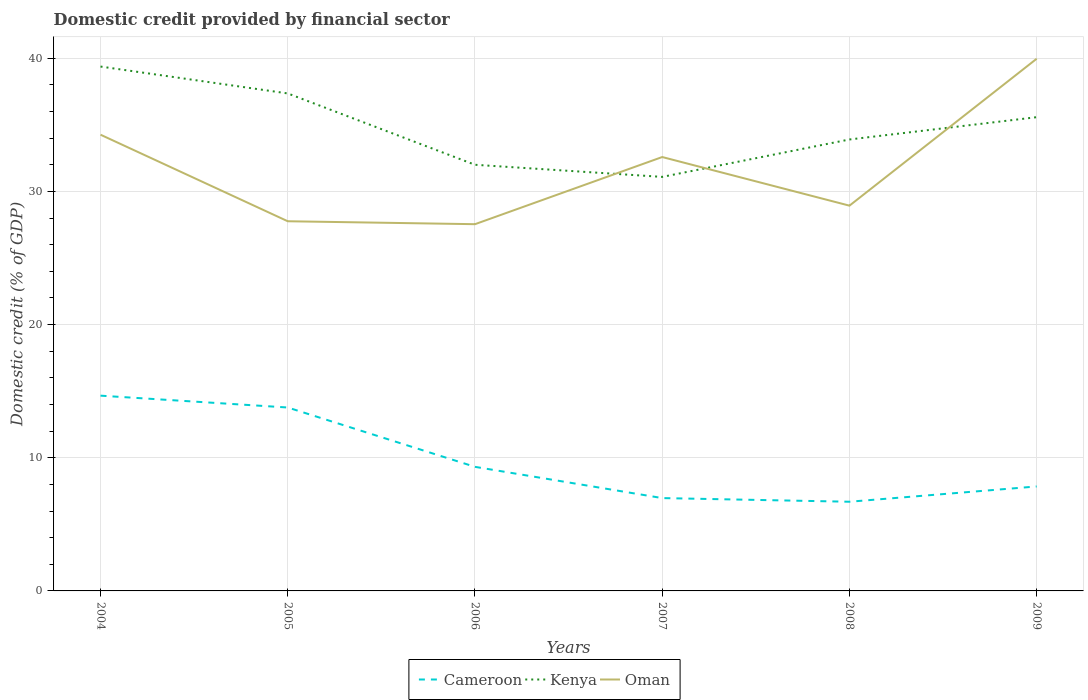Across all years, what is the maximum domestic credit in Cameroon?
Provide a short and direct response. 6.7. What is the total domestic credit in Oman in the graph?
Provide a succinct answer. -1.39. What is the difference between the highest and the second highest domestic credit in Cameroon?
Give a very brief answer. 7.97. What is the difference between two consecutive major ticks on the Y-axis?
Ensure brevity in your answer.  10. Are the values on the major ticks of Y-axis written in scientific E-notation?
Ensure brevity in your answer.  No. Where does the legend appear in the graph?
Your answer should be compact. Bottom center. How many legend labels are there?
Offer a terse response. 3. What is the title of the graph?
Your answer should be compact. Domestic credit provided by financial sector. What is the label or title of the X-axis?
Ensure brevity in your answer.  Years. What is the label or title of the Y-axis?
Your response must be concise. Domestic credit (% of GDP). What is the Domestic credit (% of GDP) in Cameroon in 2004?
Ensure brevity in your answer.  14.66. What is the Domestic credit (% of GDP) in Kenya in 2004?
Ensure brevity in your answer.  39.38. What is the Domestic credit (% of GDP) of Oman in 2004?
Give a very brief answer. 34.26. What is the Domestic credit (% of GDP) of Cameroon in 2005?
Keep it short and to the point. 13.77. What is the Domestic credit (% of GDP) of Kenya in 2005?
Ensure brevity in your answer.  37.36. What is the Domestic credit (% of GDP) in Oman in 2005?
Your response must be concise. 27.76. What is the Domestic credit (% of GDP) of Cameroon in 2006?
Provide a short and direct response. 9.32. What is the Domestic credit (% of GDP) of Kenya in 2006?
Keep it short and to the point. 32. What is the Domestic credit (% of GDP) of Oman in 2006?
Your answer should be very brief. 27.54. What is the Domestic credit (% of GDP) of Cameroon in 2007?
Provide a short and direct response. 6.97. What is the Domestic credit (% of GDP) in Kenya in 2007?
Keep it short and to the point. 31.09. What is the Domestic credit (% of GDP) of Oman in 2007?
Offer a terse response. 32.58. What is the Domestic credit (% of GDP) of Cameroon in 2008?
Offer a very short reply. 6.7. What is the Domestic credit (% of GDP) in Kenya in 2008?
Keep it short and to the point. 33.9. What is the Domestic credit (% of GDP) in Oman in 2008?
Offer a terse response. 28.93. What is the Domestic credit (% of GDP) in Cameroon in 2009?
Your response must be concise. 7.85. What is the Domestic credit (% of GDP) in Kenya in 2009?
Offer a very short reply. 35.58. What is the Domestic credit (% of GDP) of Oman in 2009?
Provide a succinct answer. 39.97. Across all years, what is the maximum Domestic credit (% of GDP) of Cameroon?
Your answer should be compact. 14.66. Across all years, what is the maximum Domestic credit (% of GDP) of Kenya?
Offer a terse response. 39.38. Across all years, what is the maximum Domestic credit (% of GDP) of Oman?
Give a very brief answer. 39.97. Across all years, what is the minimum Domestic credit (% of GDP) in Cameroon?
Provide a short and direct response. 6.7. Across all years, what is the minimum Domestic credit (% of GDP) in Kenya?
Your response must be concise. 31.09. Across all years, what is the minimum Domestic credit (% of GDP) in Oman?
Give a very brief answer. 27.54. What is the total Domestic credit (% of GDP) in Cameroon in the graph?
Your answer should be compact. 59.27. What is the total Domestic credit (% of GDP) of Kenya in the graph?
Offer a very short reply. 209.32. What is the total Domestic credit (% of GDP) in Oman in the graph?
Give a very brief answer. 191.05. What is the difference between the Domestic credit (% of GDP) in Cameroon in 2004 and that in 2005?
Your answer should be compact. 0.89. What is the difference between the Domestic credit (% of GDP) of Kenya in 2004 and that in 2005?
Provide a short and direct response. 2.02. What is the difference between the Domestic credit (% of GDP) in Oman in 2004 and that in 2005?
Your answer should be very brief. 6.5. What is the difference between the Domestic credit (% of GDP) of Cameroon in 2004 and that in 2006?
Ensure brevity in your answer.  5.35. What is the difference between the Domestic credit (% of GDP) of Kenya in 2004 and that in 2006?
Make the answer very short. 7.38. What is the difference between the Domestic credit (% of GDP) of Oman in 2004 and that in 2006?
Offer a very short reply. 6.72. What is the difference between the Domestic credit (% of GDP) of Cameroon in 2004 and that in 2007?
Provide a short and direct response. 7.69. What is the difference between the Domestic credit (% of GDP) of Kenya in 2004 and that in 2007?
Offer a very short reply. 8.29. What is the difference between the Domestic credit (% of GDP) of Oman in 2004 and that in 2007?
Make the answer very short. 1.68. What is the difference between the Domestic credit (% of GDP) of Cameroon in 2004 and that in 2008?
Provide a short and direct response. 7.97. What is the difference between the Domestic credit (% of GDP) of Kenya in 2004 and that in 2008?
Make the answer very short. 5.48. What is the difference between the Domestic credit (% of GDP) in Oman in 2004 and that in 2008?
Offer a terse response. 5.33. What is the difference between the Domestic credit (% of GDP) in Cameroon in 2004 and that in 2009?
Provide a short and direct response. 6.82. What is the difference between the Domestic credit (% of GDP) in Kenya in 2004 and that in 2009?
Make the answer very short. 3.8. What is the difference between the Domestic credit (% of GDP) in Oman in 2004 and that in 2009?
Keep it short and to the point. -5.71. What is the difference between the Domestic credit (% of GDP) of Cameroon in 2005 and that in 2006?
Make the answer very short. 4.46. What is the difference between the Domestic credit (% of GDP) in Kenya in 2005 and that in 2006?
Your answer should be very brief. 5.36. What is the difference between the Domestic credit (% of GDP) of Oman in 2005 and that in 2006?
Provide a short and direct response. 0.22. What is the difference between the Domestic credit (% of GDP) in Cameroon in 2005 and that in 2007?
Your answer should be compact. 6.8. What is the difference between the Domestic credit (% of GDP) in Kenya in 2005 and that in 2007?
Your response must be concise. 6.27. What is the difference between the Domestic credit (% of GDP) in Oman in 2005 and that in 2007?
Provide a short and direct response. -4.82. What is the difference between the Domestic credit (% of GDP) of Cameroon in 2005 and that in 2008?
Your answer should be very brief. 7.08. What is the difference between the Domestic credit (% of GDP) in Kenya in 2005 and that in 2008?
Make the answer very short. 3.46. What is the difference between the Domestic credit (% of GDP) in Oman in 2005 and that in 2008?
Make the answer very short. -1.17. What is the difference between the Domestic credit (% of GDP) of Cameroon in 2005 and that in 2009?
Your answer should be very brief. 5.93. What is the difference between the Domestic credit (% of GDP) of Kenya in 2005 and that in 2009?
Your answer should be very brief. 1.78. What is the difference between the Domestic credit (% of GDP) in Oman in 2005 and that in 2009?
Your answer should be very brief. -12.21. What is the difference between the Domestic credit (% of GDP) of Cameroon in 2006 and that in 2007?
Your answer should be compact. 2.35. What is the difference between the Domestic credit (% of GDP) of Kenya in 2006 and that in 2007?
Offer a terse response. 0.91. What is the difference between the Domestic credit (% of GDP) in Oman in 2006 and that in 2007?
Make the answer very short. -5.04. What is the difference between the Domestic credit (% of GDP) in Cameroon in 2006 and that in 2008?
Provide a succinct answer. 2.62. What is the difference between the Domestic credit (% of GDP) in Kenya in 2006 and that in 2008?
Your answer should be very brief. -1.9. What is the difference between the Domestic credit (% of GDP) in Oman in 2006 and that in 2008?
Keep it short and to the point. -1.39. What is the difference between the Domestic credit (% of GDP) of Cameroon in 2006 and that in 2009?
Make the answer very short. 1.47. What is the difference between the Domestic credit (% of GDP) in Kenya in 2006 and that in 2009?
Provide a short and direct response. -3.57. What is the difference between the Domestic credit (% of GDP) in Oman in 2006 and that in 2009?
Your answer should be very brief. -12.43. What is the difference between the Domestic credit (% of GDP) of Cameroon in 2007 and that in 2008?
Provide a short and direct response. 0.27. What is the difference between the Domestic credit (% of GDP) in Kenya in 2007 and that in 2008?
Your answer should be very brief. -2.81. What is the difference between the Domestic credit (% of GDP) in Oman in 2007 and that in 2008?
Provide a succinct answer. 3.65. What is the difference between the Domestic credit (% of GDP) in Cameroon in 2007 and that in 2009?
Offer a very short reply. -0.87. What is the difference between the Domestic credit (% of GDP) of Kenya in 2007 and that in 2009?
Offer a very short reply. -4.48. What is the difference between the Domestic credit (% of GDP) of Oman in 2007 and that in 2009?
Your response must be concise. -7.38. What is the difference between the Domestic credit (% of GDP) of Cameroon in 2008 and that in 2009?
Provide a short and direct response. -1.15. What is the difference between the Domestic credit (% of GDP) of Kenya in 2008 and that in 2009?
Keep it short and to the point. -1.67. What is the difference between the Domestic credit (% of GDP) in Oman in 2008 and that in 2009?
Provide a succinct answer. -11.03. What is the difference between the Domestic credit (% of GDP) in Cameroon in 2004 and the Domestic credit (% of GDP) in Kenya in 2005?
Offer a terse response. -22.7. What is the difference between the Domestic credit (% of GDP) in Cameroon in 2004 and the Domestic credit (% of GDP) in Oman in 2005?
Make the answer very short. -13.1. What is the difference between the Domestic credit (% of GDP) in Kenya in 2004 and the Domestic credit (% of GDP) in Oman in 2005?
Offer a very short reply. 11.62. What is the difference between the Domestic credit (% of GDP) in Cameroon in 2004 and the Domestic credit (% of GDP) in Kenya in 2006?
Make the answer very short. -17.34. What is the difference between the Domestic credit (% of GDP) in Cameroon in 2004 and the Domestic credit (% of GDP) in Oman in 2006?
Give a very brief answer. -12.88. What is the difference between the Domestic credit (% of GDP) of Kenya in 2004 and the Domestic credit (% of GDP) of Oman in 2006?
Your answer should be compact. 11.84. What is the difference between the Domestic credit (% of GDP) in Cameroon in 2004 and the Domestic credit (% of GDP) in Kenya in 2007?
Offer a terse response. -16.43. What is the difference between the Domestic credit (% of GDP) of Cameroon in 2004 and the Domestic credit (% of GDP) of Oman in 2007?
Offer a very short reply. -17.92. What is the difference between the Domestic credit (% of GDP) of Kenya in 2004 and the Domestic credit (% of GDP) of Oman in 2007?
Provide a succinct answer. 6.8. What is the difference between the Domestic credit (% of GDP) in Cameroon in 2004 and the Domestic credit (% of GDP) in Kenya in 2008?
Your answer should be compact. -19.24. What is the difference between the Domestic credit (% of GDP) in Cameroon in 2004 and the Domestic credit (% of GDP) in Oman in 2008?
Your response must be concise. -14.27. What is the difference between the Domestic credit (% of GDP) of Kenya in 2004 and the Domestic credit (% of GDP) of Oman in 2008?
Your answer should be compact. 10.45. What is the difference between the Domestic credit (% of GDP) in Cameroon in 2004 and the Domestic credit (% of GDP) in Kenya in 2009?
Give a very brief answer. -20.91. What is the difference between the Domestic credit (% of GDP) in Cameroon in 2004 and the Domestic credit (% of GDP) in Oman in 2009?
Your answer should be very brief. -25.3. What is the difference between the Domestic credit (% of GDP) in Kenya in 2004 and the Domestic credit (% of GDP) in Oman in 2009?
Ensure brevity in your answer.  -0.59. What is the difference between the Domestic credit (% of GDP) of Cameroon in 2005 and the Domestic credit (% of GDP) of Kenya in 2006?
Your response must be concise. -18.23. What is the difference between the Domestic credit (% of GDP) in Cameroon in 2005 and the Domestic credit (% of GDP) in Oman in 2006?
Keep it short and to the point. -13.77. What is the difference between the Domestic credit (% of GDP) of Kenya in 2005 and the Domestic credit (% of GDP) of Oman in 2006?
Provide a succinct answer. 9.82. What is the difference between the Domestic credit (% of GDP) of Cameroon in 2005 and the Domestic credit (% of GDP) of Kenya in 2007?
Your answer should be compact. -17.32. What is the difference between the Domestic credit (% of GDP) in Cameroon in 2005 and the Domestic credit (% of GDP) in Oman in 2007?
Your response must be concise. -18.81. What is the difference between the Domestic credit (% of GDP) in Kenya in 2005 and the Domestic credit (% of GDP) in Oman in 2007?
Offer a very short reply. 4.78. What is the difference between the Domestic credit (% of GDP) in Cameroon in 2005 and the Domestic credit (% of GDP) in Kenya in 2008?
Offer a terse response. -20.13. What is the difference between the Domestic credit (% of GDP) of Cameroon in 2005 and the Domestic credit (% of GDP) of Oman in 2008?
Ensure brevity in your answer.  -15.16. What is the difference between the Domestic credit (% of GDP) in Kenya in 2005 and the Domestic credit (% of GDP) in Oman in 2008?
Keep it short and to the point. 8.43. What is the difference between the Domestic credit (% of GDP) in Cameroon in 2005 and the Domestic credit (% of GDP) in Kenya in 2009?
Keep it short and to the point. -21.8. What is the difference between the Domestic credit (% of GDP) in Cameroon in 2005 and the Domestic credit (% of GDP) in Oman in 2009?
Offer a very short reply. -26.19. What is the difference between the Domestic credit (% of GDP) in Kenya in 2005 and the Domestic credit (% of GDP) in Oman in 2009?
Ensure brevity in your answer.  -2.61. What is the difference between the Domestic credit (% of GDP) of Cameroon in 2006 and the Domestic credit (% of GDP) of Kenya in 2007?
Keep it short and to the point. -21.77. What is the difference between the Domestic credit (% of GDP) of Cameroon in 2006 and the Domestic credit (% of GDP) of Oman in 2007?
Ensure brevity in your answer.  -23.27. What is the difference between the Domestic credit (% of GDP) in Kenya in 2006 and the Domestic credit (% of GDP) in Oman in 2007?
Give a very brief answer. -0.58. What is the difference between the Domestic credit (% of GDP) of Cameroon in 2006 and the Domestic credit (% of GDP) of Kenya in 2008?
Provide a succinct answer. -24.58. What is the difference between the Domestic credit (% of GDP) of Cameroon in 2006 and the Domestic credit (% of GDP) of Oman in 2008?
Your response must be concise. -19.61. What is the difference between the Domestic credit (% of GDP) of Kenya in 2006 and the Domestic credit (% of GDP) of Oman in 2008?
Provide a short and direct response. 3.07. What is the difference between the Domestic credit (% of GDP) in Cameroon in 2006 and the Domestic credit (% of GDP) in Kenya in 2009?
Give a very brief answer. -26.26. What is the difference between the Domestic credit (% of GDP) in Cameroon in 2006 and the Domestic credit (% of GDP) in Oman in 2009?
Your answer should be compact. -30.65. What is the difference between the Domestic credit (% of GDP) of Kenya in 2006 and the Domestic credit (% of GDP) of Oman in 2009?
Offer a terse response. -7.96. What is the difference between the Domestic credit (% of GDP) of Cameroon in 2007 and the Domestic credit (% of GDP) of Kenya in 2008?
Your answer should be compact. -26.93. What is the difference between the Domestic credit (% of GDP) in Cameroon in 2007 and the Domestic credit (% of GDP) in Oman in 2008?
Provide a short and direct response. -21.96. What is the difference between the Domestic credit (% of GDP) in Kenya in 2007 and the Domestic credit (% of GDP) in Oman in 2008?
Ensure brevity in your answer.  2.16. What is the difference between the Domestic credit (% of GDP) of Cameroon in 2007 and the Domestic credit (% of GDP) of Kenya in 2009?
Your response must be concise. -28.6. What is the difference between the Domestic credit (% of GDP) in Cameroon in 2007 and the Domestic credit (% of GDP) in Oman in 2009?
Provide a succinct answer. -32.99. What is the difference between the Domestic credit (% of GDP) in Kenya in 2007 and the Domestic credit (% of GDP) in Oman in 2009?
Provide a short and direct response. -8.87. What is the difference between the Domestic credit (% of GDP) of Cameroon in 2008 and the Domestic credit (% of GDP) of Kenya in 2009?
Your answer should be very brief. -28.88. What is the difference between the Domestic credit (% of GDP) in Cameroon in 2008 and the Domestic credit (% of GDP) in Oman in 2009?
Your response must be concise. -33.27. What is the difference between the Domestic credit (% of GDP) of Kenya in 2008 and the Domestic credit (% of GDP) of Oman in 2009?
Offer a terse response. -6.06. What is the average Domestic credit (% of GDP) in Cameroon per year?
Your answer should be very brief. 9.88. What is the average Domestic credit (% of GDP) in Kenya per year?
Your answer should be compact. 34.89. What is the average Domestic credit (% of GDP) in Oman per year?
Your response must be concise. 31.84. In the year 2004, what is the difference between the Domestic credit (% of GDP) of Cameroon and Domestic credit (% of GDP) of Kenya?
Make the answer very short. -24.72. In the year 2004, what is the difference between the Domestic credit (% of GDP) in Cameroon and Domestic credit (% of GDP) in Oman?
Keep it short and to the point. -19.6. In the year 2004, what is the difference between the Domestic credit (% of GDP) in Kenya and Domestic credit (% of GDP) in Oman?
Give a very brief answer. 5.12. In the year 2005, what is the difference between the Domestic credit (% of GDP) of Cameroon and Domestic credit (% of GDP) of Kenya?
Keep it short and to the point. -23.59. In the year 2005, what is the difference between the Domestic credit (% of GDP) in Cameroon and Domestic credit (% of GDP) in Oman?
Your response must be concise. -13.99. In the year 2005, what is the difference between the Domestic credit (% of GDP) in Kenya and Domestic credit (% of GDP) in Oman?
Provide a succinct answer. 9.6. In the year 2006, what is the difference between the Domestic credit (% of GDP) in Cameroon and Domestic credit (% of GDP) in Kenya?
Offer a very short reply. -22.68. In the year 2006, what is the difference between the Domestic credit (% of GDP) in Cameroon and Domestic credit (% of GDP) in Oman?
Ensure brevity in your answer.  -18.22. In the year 2006, what is the difference between the Domestic credit (% of GDP) in Kenya and Domestic credit (% of GDP) in Oman?
Offer a terse response. 4.46. In the year 2007, what is the difference between the Domestic credit (% of GDP) in Cameroon and Domestic credit (% of GDP) in Kenya?
Offer a very short reply. -24.12. In the year 2007, what is the difference between the Domestic credit (% of GDP) of Cameroon and Domestic credit (% of GDP) of Oman?
Your answer should be compact. -25.61. In the year 2007, what is the difference between the Domestic credit (% of GDP) in Kenya and Domestic credit (% of GDP) in Oman?
Make the answer very short. -1.49. In the year 2008, what is the difference between the Domestic credit (% of GDP) of Cameroon and Domestic credit (% of GDP) of Kenya?
Your response must be concise. -27.21. In the year 2008, what is the difference between the Domestic credit (% of GDP) in Cameroon and Domestic credit (% of GDP) in Oman?
Provide a short and direct response. -22.24. In the year 2008, what is the difference between the Domestic credit (% of GDP) of Kenya and Domestic credit (% of GDP) of Oman?
Provide a succinct answer. 4.97. In the year 2009, what is the difference between the Domestic credit (% of GDP) of Cameroon and Domestic credit (% of GDP) of Kenya?
Your answer should be compact. -27.73. In the year 2009, what is the difference between the Domestic credit (% of GDP) of Cameroon and Domestic credit (% of GDP) of Oman?
Provide a succinct answer. -32.12. In the year 2009, what is the difference between the Domestic credit (% of GDP) in Kenya and Domestic credit (% of GDP) in Oman?
Offer a very short reply. -4.39. What is the ratio of the Domestic credit (% of GDP) of Cameroon in 2004 to that in 2005?
Make the answer very short. 1.06. What is the ratio of the Domestic credit (% of GDP) of Kenya in 2004 to that in 2005?
Give a very brief answer. 1.05. What is the ratio of the Domestic credit (% of GDP) of Oman in 2004 to that in 2005?
Ensure brevity in your answer.  1.23. What is the ratio of the Domestic credit (% of GDP) in Cameroon in 2004 to that in 2006?
Provide a succinct answer. 1.57. What is the ratio of the Domestic credit (% of GDP) of Kenya in 2004 to that in 2006?
Provide a succinct answer. 1.23. What is the ratio of the Domestic credit (% of GDP) of Oman in 2004 to that in 2006?
Offer a terse response. 1.24. What is the ratio of the Domestic credit (% of GDP) in Cameroon in 2004 to that in 2007?
Give a very brief answer. 2.1. What is the ratio of the Domestic credit (% of GDP) of Kenya in 2004 to that in 2007?
Offer a terse response. 1.27. What is the ratio of the Domestic credit (% of GDP) in Oman in 2004 to that in 2007?
Provide a succinct answer. 1.05. What is the ratio of the Domestic credit (% of GDP) in Cameroon in 2004 to that in 2008?
Make the answer very short. 2.19. What is the ratio of the Domestic credit (% of GDP) of Kenya in 2004 to that in 2008?
Your answer should be compact. 1.16. What is the ratio of the Domestic credit (% of GDP) in Oman in 2004 to that in 2008?
Keep it short and to the point. 1.18. What is the ratio of the Domestic credit (% of GDP) of Cameroon in 2004 to that in 2009?
Your response must be concise. 1.87. What is the ratio of the Domestic credit (% of GDP) of Kenya in 2004 to that in 2009?
Your answer should be compact. 1.11. What is the ratio of the Domestic credit (% of GDP) of Oman in 2004 to that in 2009?
Ensure brevity in your answer.  0.86. What is the ratio of the Domestic credit (% of GDP) of Cameroon in 2005 to that in 2006?
Your response must be concise. 1.48. What is the ratio of the Domestic credit (% of GDP) in Kenya in 2005 to that in 2006?
Your answer should be very brief. 1.17. What is the ratio of the Domestic credit (% of GDP) in Cameroon in 2005 to that in 2007?
Your answer should be compact. 1.98. What is the ratio of the Domestic credit (% of GDP) of Kenya in 2005 to that in 2007?
Provide a succinct answer. 1.2. What is the ratio of the Domestic credit (% of GDP) in Oman in 2005 to that in 2007?
Your response must be concise. 0.85. What is the ratio of the Domestic credit (% of GDP) of Cameroon in 2005 to that in 2008?
Provide a short and direct response. 2.06. What is the ratio of the Domestic credit (% of GDP) of Kenya in 2005 to that in 2008?
Make the answer very short. 1.1. What is the ratio of the Domestic credit (% of GDP) in Oman in 2005 to that in 2008?
Offer a very short reply. 0.96. What is the ratio of the Domestic credit (% of GDP) in Cameroon in 2005 to that in 2009?
Give a very brief answer. 1.76. What is the ratio of the Domestic credit (% of GDP) of Kenya in 2005 to that in 2009?
Ensure brevity in your answer.  1.05. What is the ratio of the Domestic credit (% of GDP) of Oman in 2005 to that in 2009?
Provide a short and direct response. 0.69. What is the ratio of the Domestic credit (% of GDP) in Cameroon in 2006 to that in 2007?
Give a very brief answer. 1.34. What is the ratio of the Domestic credit (% of GDP) of Kenya in 2006 to that in 2007?
Ensure brevity in your answer.  1.03. What is the ratio of the Domestic credit (% of GDP) in Oman in 2006 to that in 2007?
Your response must be concise. 0.85. What is the ratio of the Domestic credit (% of GDP) in Cameroon in 2006 to that in 2008?
Give a very brief answer. 1.39. What is the ratio of the Domestic credit (% of GDP) in Kenya in 2006 to that in 2008?
Your answer should be compact. 0.94. What is the ratio of the Domestic credit (% of GDP) of Oman in 2006 to that in 2008?
Provide a short and direct response. 0.95. What is the ratio of the Domestic credit (% of GDP) in Cameroon in 2006 to that in 2009?
Provide a succinct answer. 1.19. What is the ratio of the Domestic credit (% of GDP) in Kenya in 2006 to that in 2009?
Your answer should be compact. 0.9. What is the ratio of the Domestic credit (% of GDP) in Oman in 2006 to that in 2009?
Make the answer very short. 0.69. What is the ratio of the Domestic credit (% of GDP) of Cameroon in 2007 to that in 2008?
Give a very brief answer. 1.04. What is the ratio of the Domestic credit (% of GDP) of Kenya in 2007 to that in 2008?
Ensure brevity in your answer.  0.92. What is the ratio of the Domestic credit (% of GDP) in Oman in 2007 to that in 2008?
Your answer should be very brief. 1.13. What is the ratio of the Domestic credit (% of GDP) in Cameroon in 2007 to that in 2009?
Your answer should be very brief. 0.89. What is the ratio of the Domestic credit (% of GDP) in Kenya in 2007 to that in 2009?
Keep it short and to the point. 0.87. What is the ratio of the Domestic credit (% of GDP) of Oman in 2007 to that in 2009?
Provide a succinct answer. 0.82. What is the ratio of the Domestic credit (% of GDP) in Cameroon in 2008 to that in 2009?
Your response must be concise. 0.85. What is the ratio of the Domestic credit (% of GDP) of Kenya in 2008 to that in 2009?
Offer a very short reply. 0.95. What is the ratio of the Domestic credit (% of GDP) in Oman in 2008 to that in 2009?
Give a very brief answer. 0.72. What is the difference between the highest and the second highest Domestic credit (% of GDP) of Cameroon?
Your response must be concise. 0.89. What is the difference between the highest and the second highest Domestic credit (% of GDP) in Kenya?
Your answer should be compact. 2.02. What is the difference between the highest and the second highest Domestic credit (% of GDP) of Oman?
Your answer should be very brief. 5.71. What is the difference between the highest and the lowest Domestic credit (% of GDP) in Cameroon?
Your answer should be very brief. 7.97. What is the difference between the highest and the lowest Domestic credit (% of GDP) of Kenya?
Your response must be concise. 8.29. What is the difference between the highest and the lowest Domestic credit (% of GDP) in Oman?
Provide a succinct answer. 12.43. 